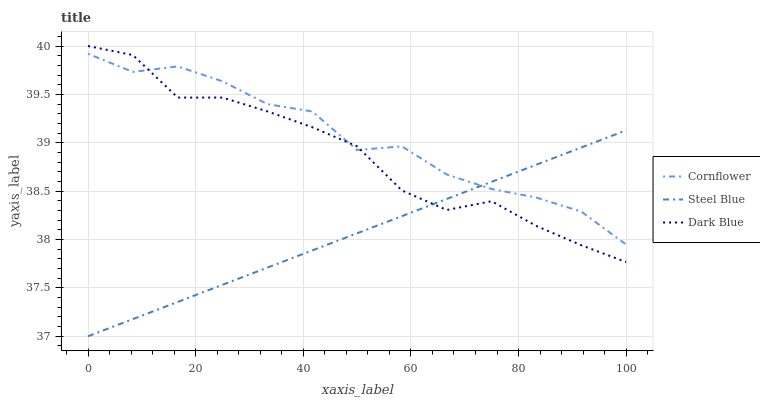Does Dark Blue have the minimum area under the curve?
Answer yes or no. No. Does Dark Blue have the maximum area under the curve?
Answer yes or no. No. Is Dark Blue the smoothest?
Answer yes or no. No. Is Dark Blue the roughest?
Answer yes or no. No. Does Dark Blue have the lowest value?
Answer yes or no. No. Does Steel Blue have the highest value?
Answer yes or no. No. 